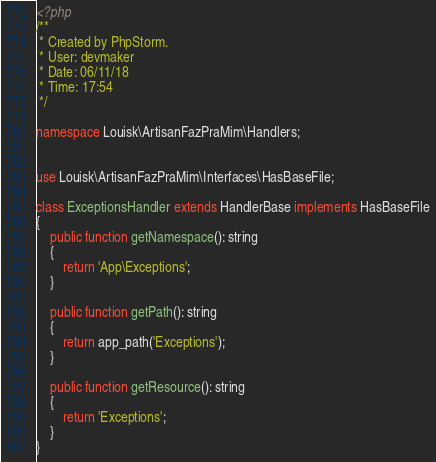<code> <loc_0><loc_0><loc_500><loc_500><_PHP_><?php
/**
 * Created by PhpStorm.
 * User: devmaker
 * Date: 06/11/18
 * Time: 17:54
 */

namespace Louisk\ArtisanFazPraMim\Handlers;


use Louisk\ArtisanFazPraMim\Interfaces\HasBaseFile;

class ExceptionsHandler extends HandlerBase implements HasBaseFile
{
    public function getNamespace(): string
    {
        return 'App\Exceptions';
    }

    public function getPath(): string
    {
        return app_path('Exceptions');
    }

    public function getResource(): string
    {
        return 'Exceptions';
    }
}
</code> 